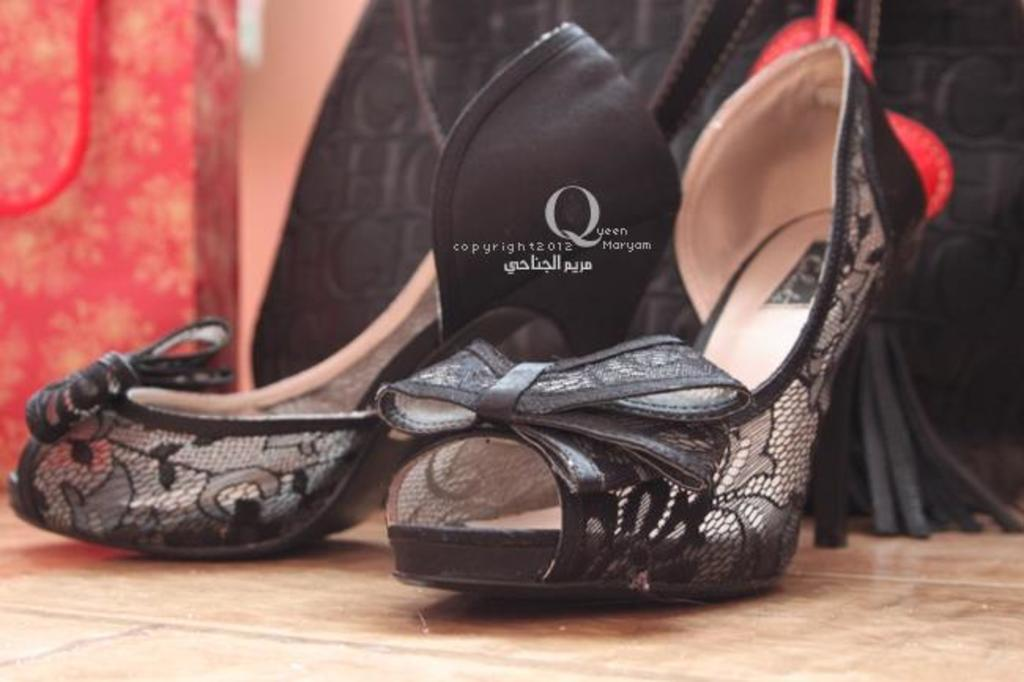What type of item is located in the front of the image? There is footwear in the front of the image. What can be seen in the background of the image? There is a bag in the background of the image. How does the monkey maintain its quietness in the image? There is no monkey present in the image, so it is not possible to determine how it might maintain its quietness. 